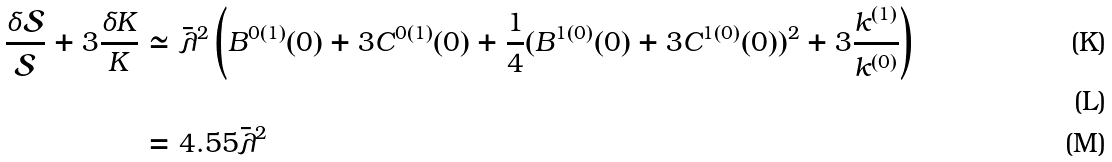Convert formula to latex. <formula><loc_0><loc_0><loc_500><loc_500>\frac { \delta \mathcal { S } } { \mathcal { S } } + 3 \frac { \delta K } { K } & \simeq \bar { \lambda } ^ { 2 } \left ( B ^ { 0 ( 1 ) } ( 0 ) + 3 C ^ { 0 ( 1 ) } ( 0 ) + \frac { 1 } { 4 } ( B ^ { 1 ( 0 ) } ( 0 ) + 3 C ^ { 1 ( 0 ) } ( 0 ) ) ^ { 2 } + 3 \frac { k ^ { ( 1 ) } } { k ^ { ( 0 ) } } \right ) \\ \\ & = 4 . 5 5 \bar { \lambda } ^ { 2 }</formula> 